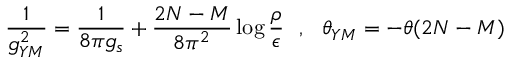<formula> <loc_0><loc_0><loc_500><loc_500>\frac { 1 } { g _ { Y M } ^ { 2 } } = \frac { 1 } { 8 \pi g _ { s } } + \frac { 2 N - M } { 8 \pi ^ { 2 } } \log \frac { \rho } { \epsilon } , \theta _ { Y M } = - \theta ( 2 N - M )</formula> 